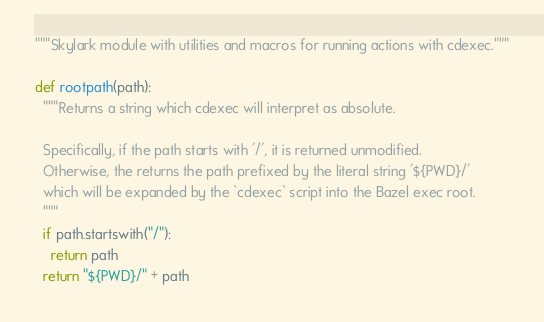<code> <loc_0><loc_0><loc_500><loc_500><_Python_>"""Skylark module with utilities and macros for running actions with cdexec."""

def rootpath(path):
  """Returns a string which cdexec will interpret as absolute.

  Specifically, if the path starts with '/', it is returned unmodified.
  Otherwise, the returns the path prefixed by the literal string '${PWD}/'
  which will be expanded by the `cdexec` script into the Bazel exec root.
  """
  if path.startswith("/"):
    return path
  return "${PWD}/" + path
</code> 